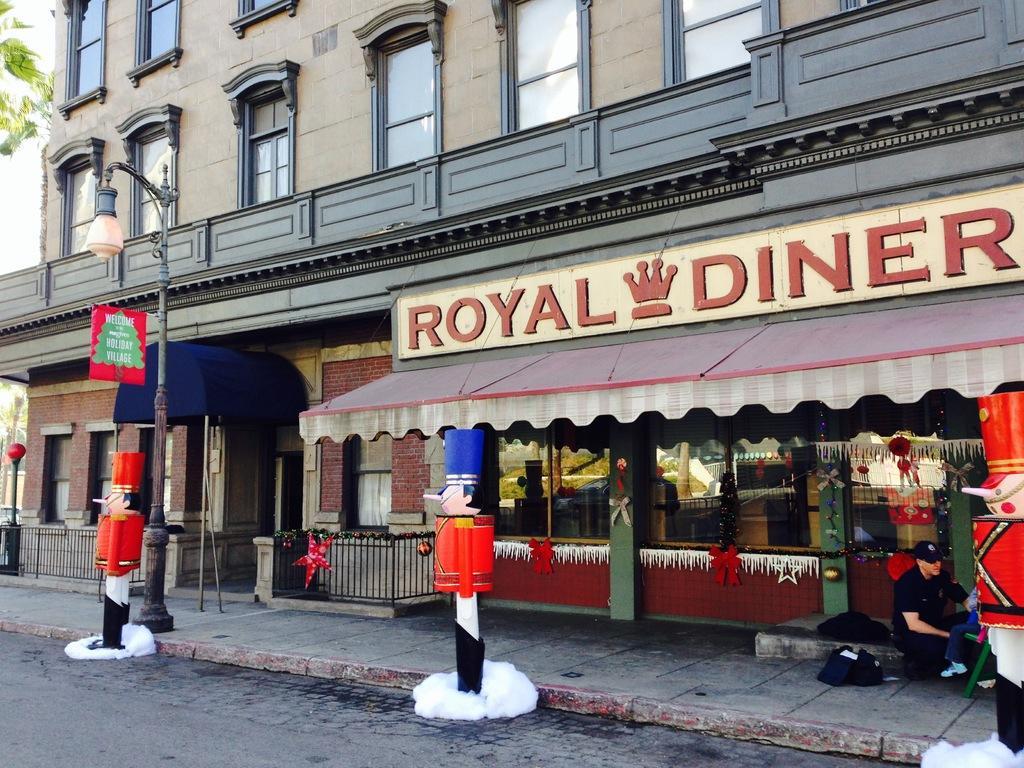Could you give a brief overview of what you see in this image? In this picture there is royal diner hotel in the image and there are windows at the top side of the image and there is a pole on the left side of the image and there are clown statues in the image. 